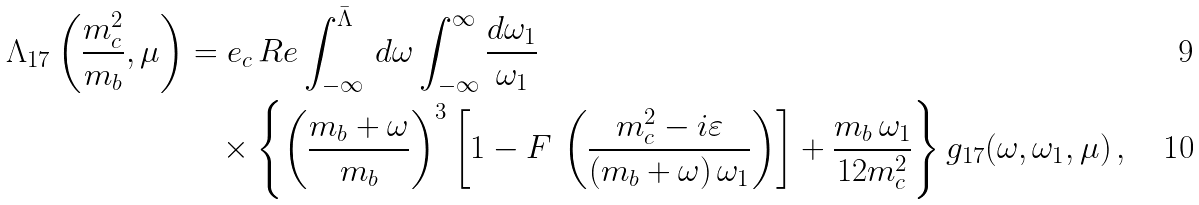Convert formula to latex. <formula><loc_0><loc_0><loc_500><loc_500>\Lambda _ { 1 7 } \left ( \frac { m _ { c } ^ { 2 } } { m _ { b } } , \mu \right ) & = e _ { c } \, R e \int _ { - \infty } ^ { \bar { \Lambda } } \, d \omega \int _ { - \infty } ^ { \infty } \frac { d \omega _ { 1 } } { \omega _ { 1 } } \\ & \quad \times \left \{ \left ( \frac { m _ { b } + \omega } { m _ { b } } \right ) ^ { 3 } \left [ 1 - F \, \left ( \frac { m _ { c } ^ { 2 } - i \varepsilon } { ( m _ { b } + \omega ) \, \omega _ { 1 } } \right ) \right ] + \frac { m _ { b } \, \omega _ { 1 } } { 1 2 m _ { c } ^ { 2 } } \right \} g _ { 1 7 } ( \omega , \omega _ { 1 } , \mu ) \, ,</formula> 